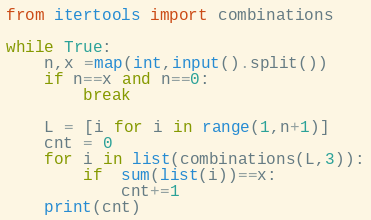Convert code to text. <code><loc_0><loc_0><loc_500><loc_500><_Python_>from itertools import combinations

while True:
    n,x =map(int,input().split())
    if n==x and n==0:
        break
    
    L = [i for i in range(1,n+1)]
    cnt = 0
    for i in list(combinations(L,3)):
        if  sum(list(i))==x:
            cnt+=1
    print(cnt)
</code> 